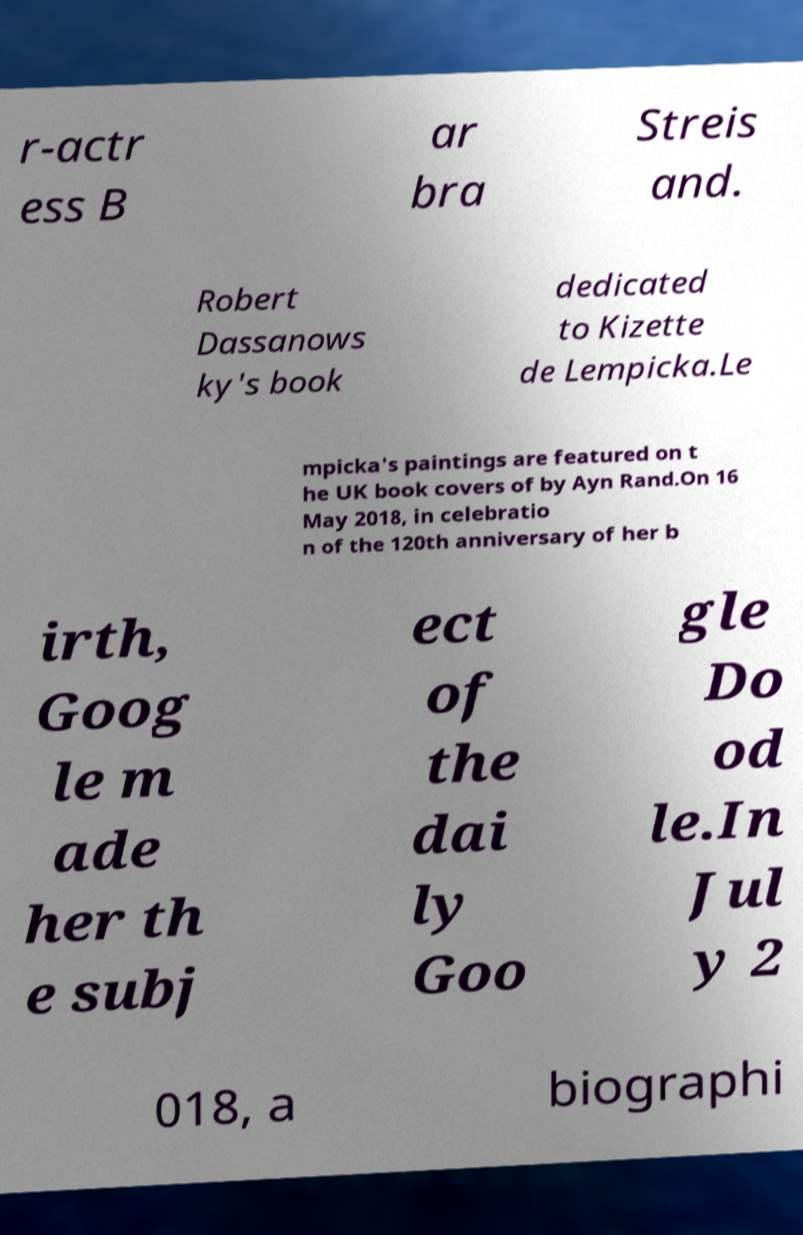Please read and relay the text visible in this image. What does it say? r-actr ess B ar bra Streis and. Robert Dassanows ky's book dedicated to Kizette de Lempicka.Le mpicka's paintings are featured on t he UK book covers of by Ayn Rand.On 16 May 2018, in celebratio n of the 120th anniversary of her b irth, Goog le m ade her th e subj ect of the dai ly Goo gle Do od le.In Jul y 2 018, a biographi 